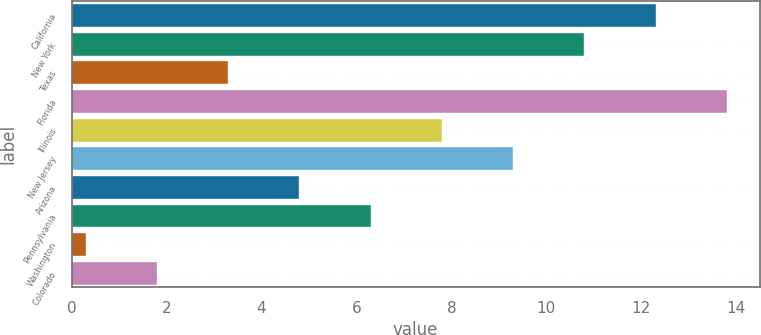Convert chart to OTSL. <chart><loc_0><loc_0><loc_500><loc_500><bar_chart><fcel>California<fcel>New York<fcel>Texas<fcel>Florida<fcel>Illinois<fcel>New Jersey<fcel>Arizona<fcel>Pennsylvania<fcel>Washington<fcel>Colorado<nl><fcel>12.3<fcel>10.8<fcel>3.3<fcel>13.8<fcel>7.8<fcel>9.3<fcel>4.8<fcel>6.3<fcel>0.3<fcel>1.8<nl></chart> 